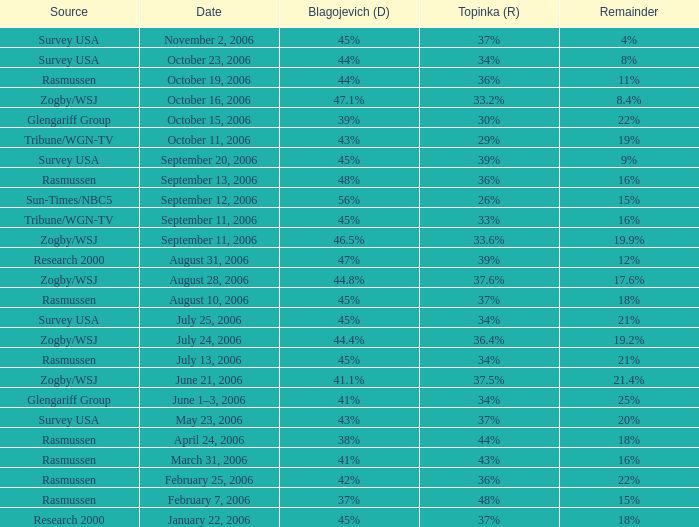Which Blagojevich (D) has a Source of zogby/wsj, and a Topinka (R) of 33.2%? 47.1%. 